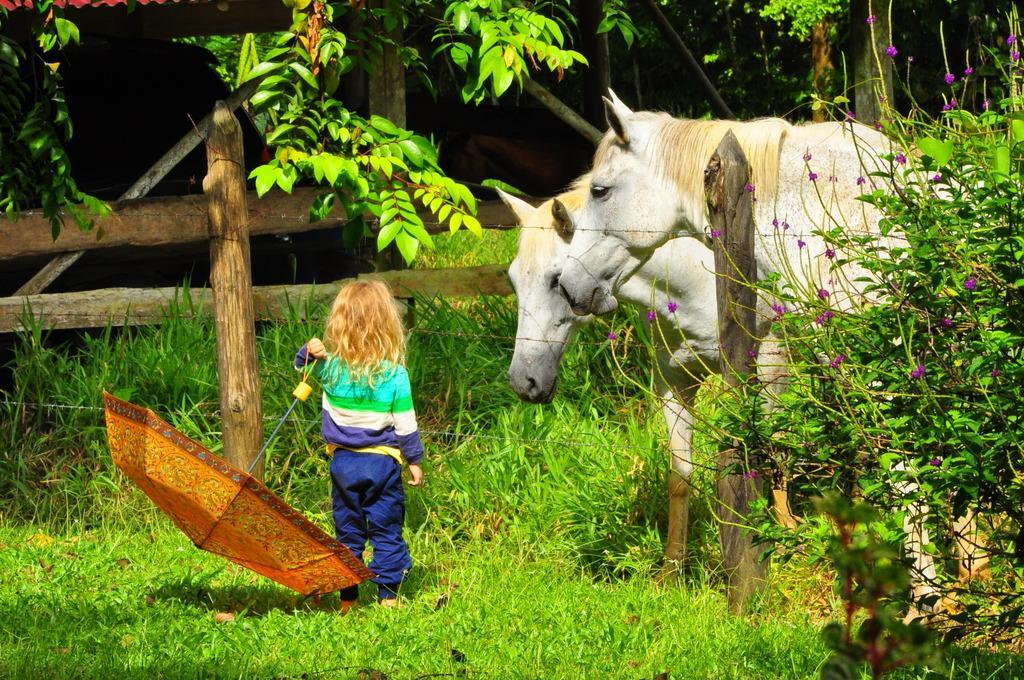Describe this image in one or two sentences. There is a kid standing on a greenery ground and holding a umbrella in her hand and there is a fence in front of her and there are two white horses on the another side of the fence and there are trees in the background. 